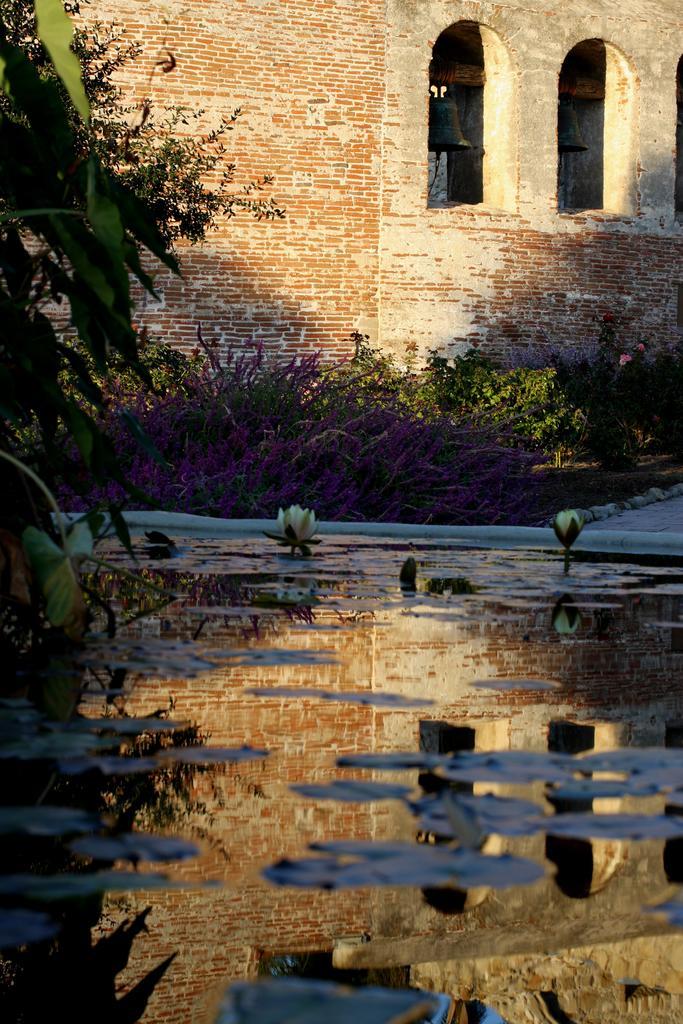Describe this image in one or two sentences. Here on the water we can see plants and flowers. On the left there is a plant. In the background there is a building and two balls hanging to the pole and we can see plants. 